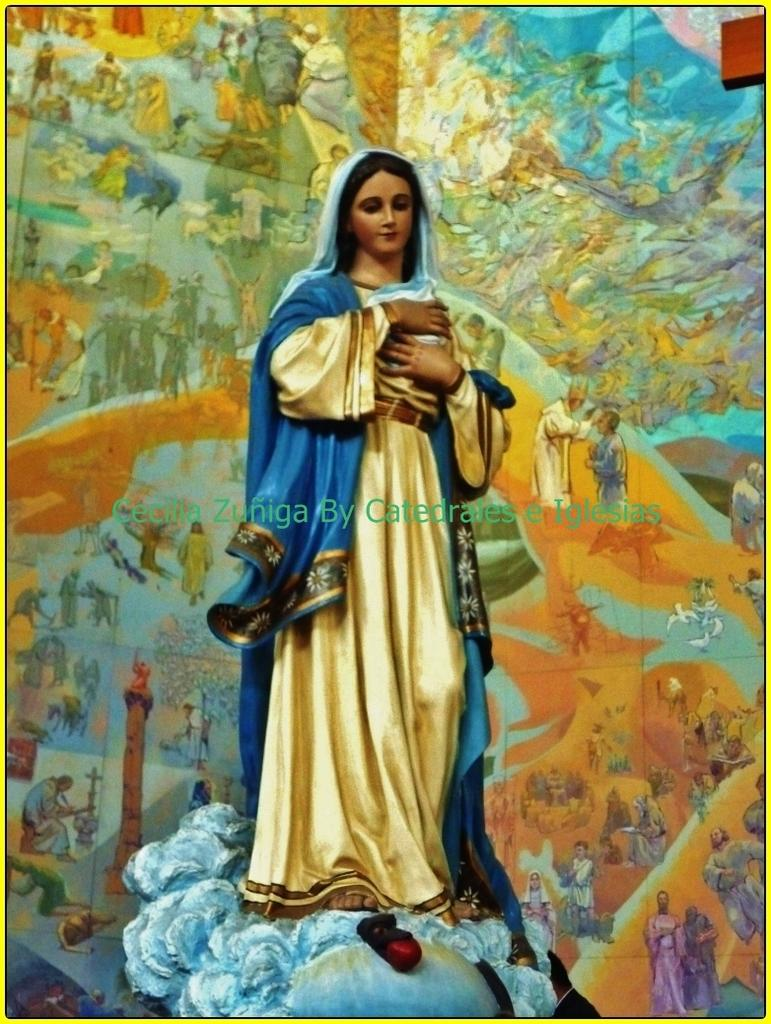What is depicted in the image? The image contains a painting of people. Can you describe the scene in the painting? There is a person standing in the painting and holding an object. What additional feature can be observed in the image? There is a watermark at the center of the image. What type of stamp is visible on the person's forehead in the painting? There is no stamp visible on the person's forehead in the painting. 